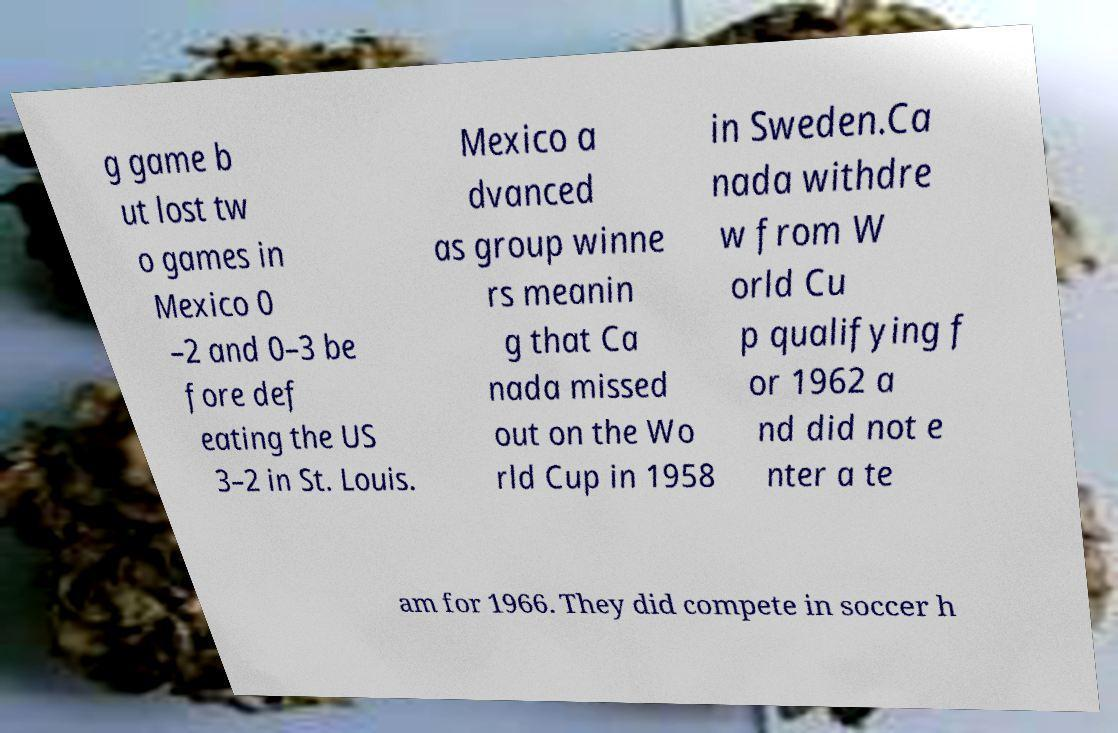Can you read and provide the text displayed in the image?This photo seems to have some interesting text. Can you extract and type it out for me? g game b ut lost tw o games in Mexico 0 –2 and 0–3 be fore def eating the US 3–2 in St. Louis. Mexico a dvanced as group winne rs meanin g that Ca nada missed out on the Wo rld Cup in 1958 in Sweden.Ca nada withdre w from W orld Cu p qualifying f or 1962 a nd did not e nter a te am for 1966. They did compete in soccer h 